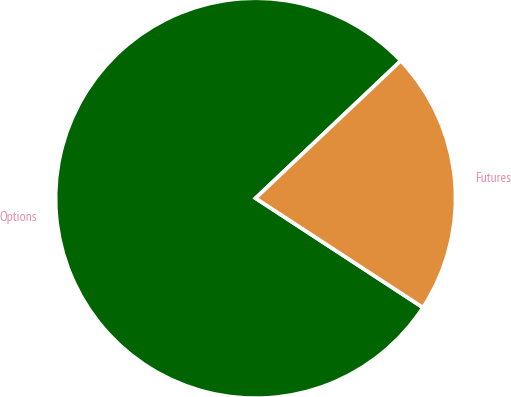Convert chart. <chart><loc_0><loc_0><loc_500><loc_500><pie_chart><fcel>Options<fcel>Futures<nl><fcel>78.73%<fcel>21.27%<nl></chart> 